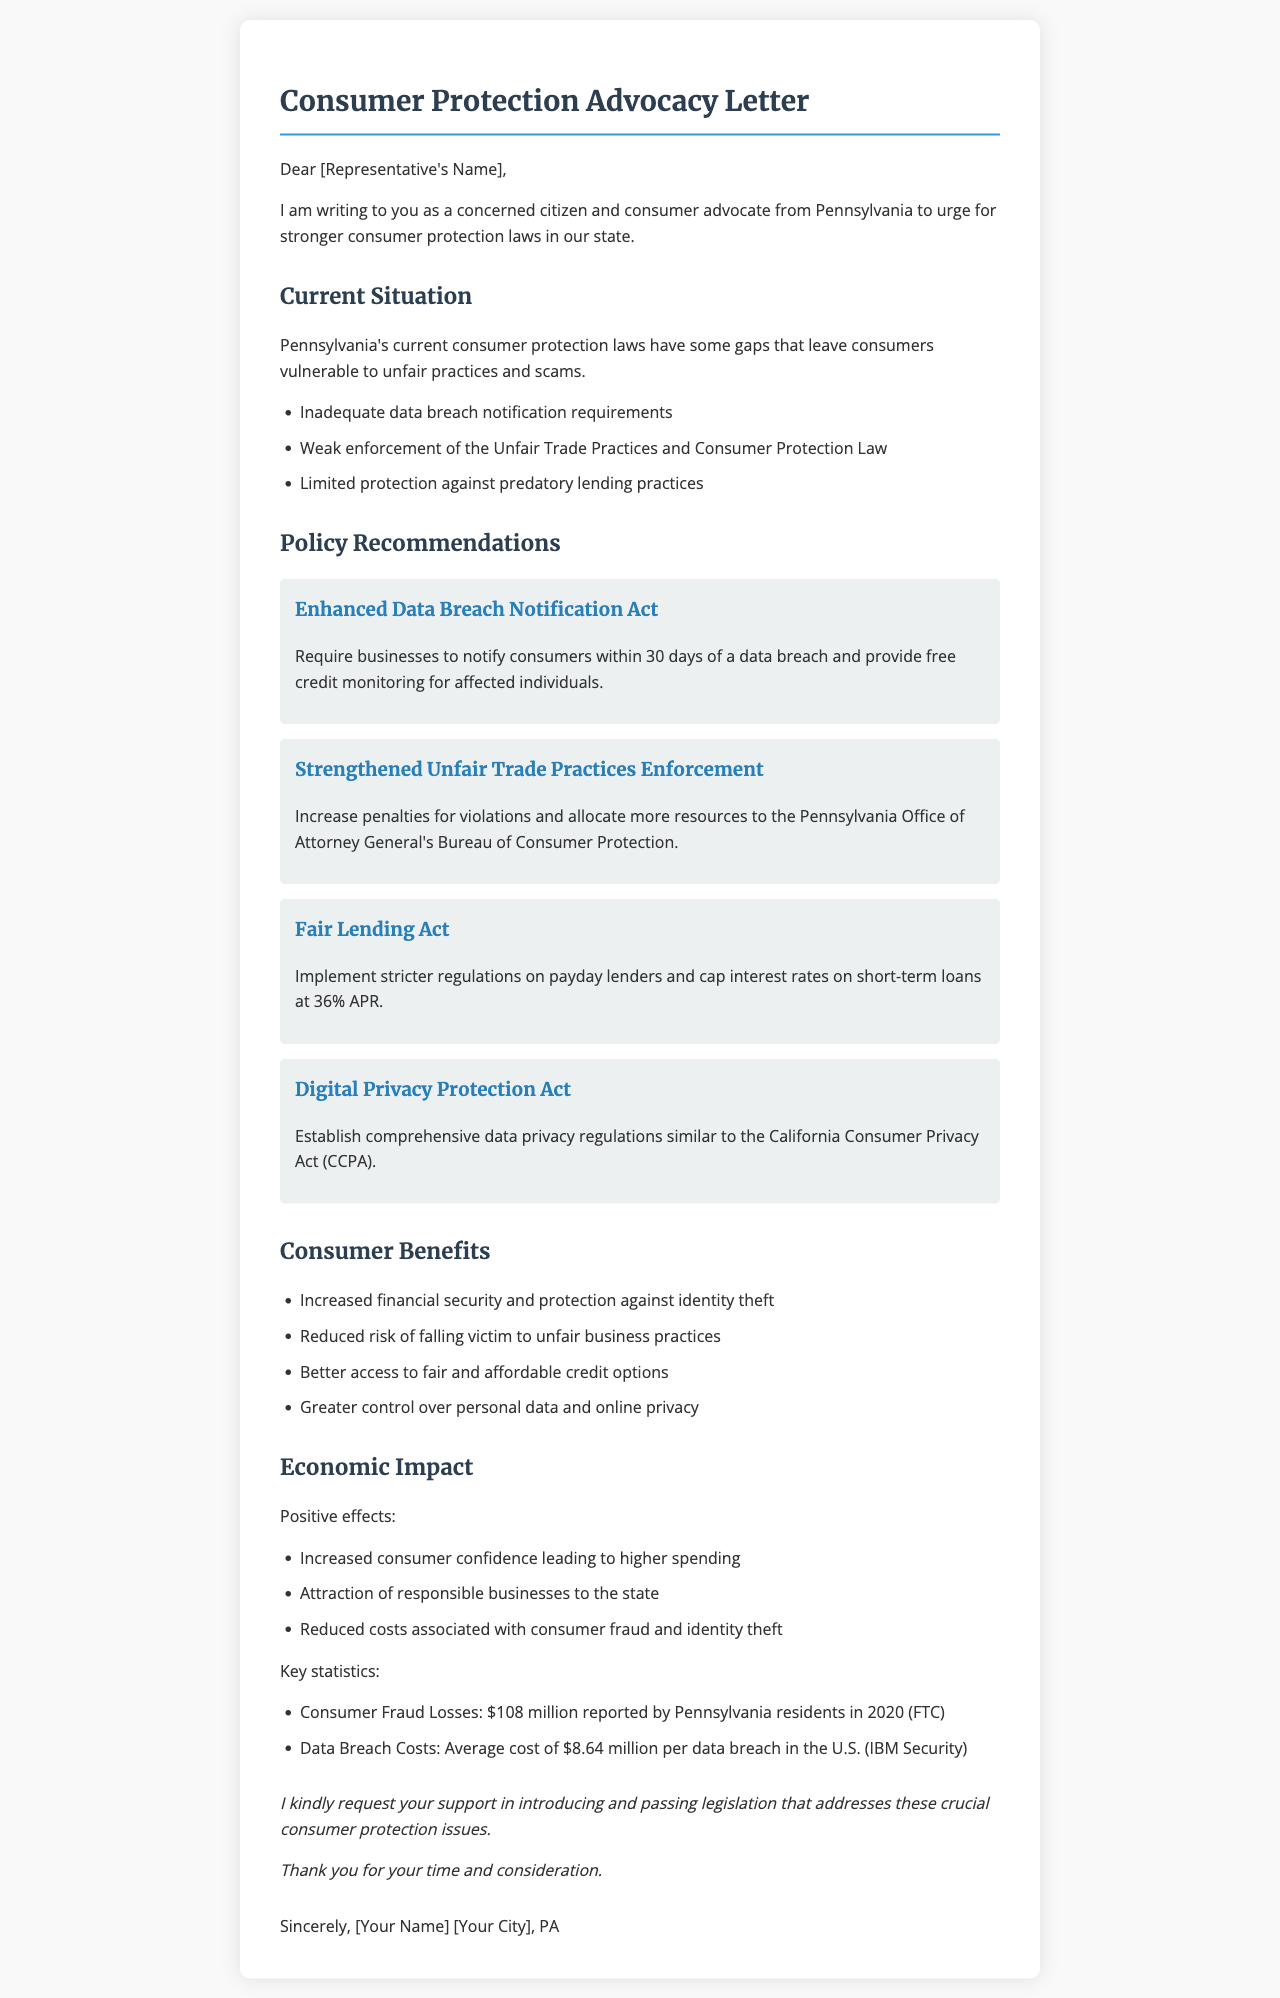What are the gaps in Pennsylvania's consumer protection laws? The document states that there are gaps leaving consumers vulnerable, specifically mentioning inadequate data breach notifications, weak enforcement of laws, and limited protection against predatory lending practices.
Answer: Inadequate data breach notification requirements, weak enforcement of the Unfair Trade Practices and Consumer Protection Law, limited protection against predatory lending practices What is the proposed Enhanced Data Breach Notification Act? The letter describes it as a requirement for businesses to notify consumers within 30 days of a data breach and provide free credit monitoring for affected individuals.
Answer: Require businesses to notify consumers within 30 days of a data breach and provide free credit monitoring for affected individuals What statistics are provided for consumer fraud losses in Pennsylvania? The document cites specific figures from the FTC regarding reported consumer fraud losses.
Answer: $108 million reported by Pennsylvania residents in 2020 What is one benefit to consumers of stronger protection laws? The letter outlines several benefits to consumers, including financial security.
Answer: Increased financial security and protection against identity theft What recent event highlighted the need for stronger data protection laws? The letter mentions a specific hearing that took place, emphasizing its relevance to consumer protection.
Answer: Pennsylvania House Consumer Affairs Committee Hearing on Data Privacy 